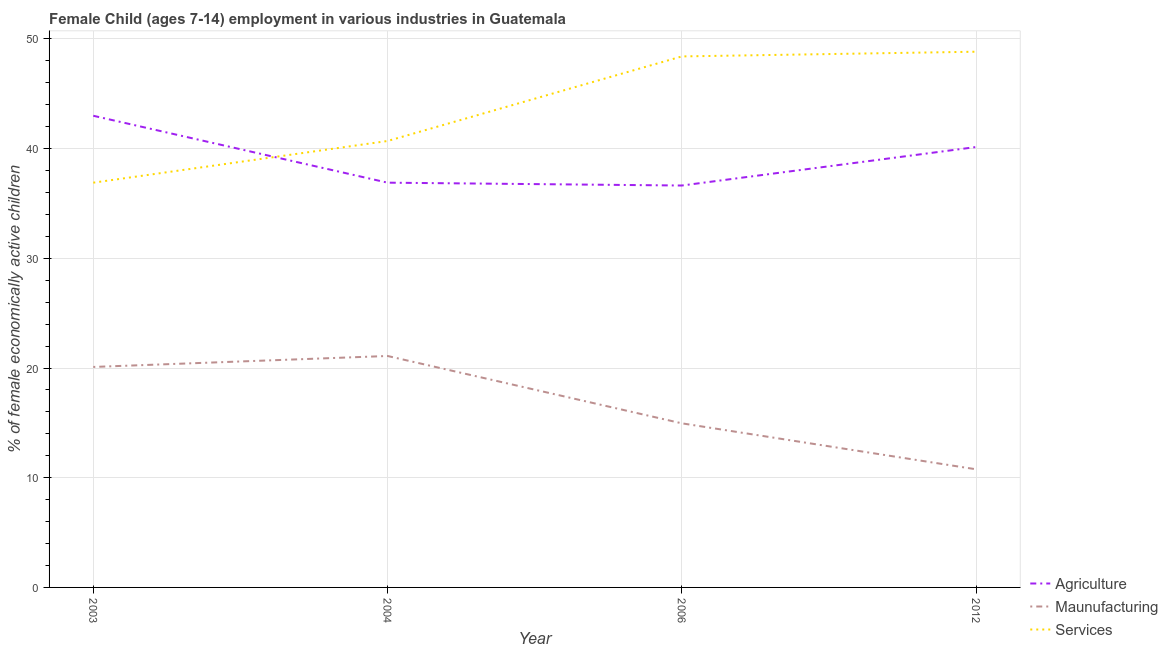Is the number of lines equal to the number of legend labels?
Offer a terse response. Yes. What is the percentage of economically active children in services in 2003?
Your response must be concise. 36.9. Across all years, what is the maximum percentage of economically active children in manufacturing?
Ensure brevity in your answer.  21.1. Across all years, what is the minimum percentage of economically active children in agriculture?
Your answer should be very brief. 36.64. What is the total percentage of economically active children in manufacturing in the graph?
Provide a succinct answer. 66.93. What is the difference between the percentage of economically active children in agriculture in 2003 and that in 2006?
Ensure brevity in your answer.  6.36. What is the difference between the percentage of economically active children in agriculture in 2006 and the percentage of economically active children in services in 2003?
Offer a terse response. -0.26. What is the average percentage of economically active children in manufacturing per year?
Keep it short and to the point. 16.73. In the year 2004, what is the difference between the percentage of economically active children in agriculture and percentage of economically active children in manufacturing?
Provide a succinct answer. 15.8. What is the ratio of the percentage of economically active children in agriculture in 2003 to that in 2004?
Offer a terse response. 1.17. Is the difference between the percentage of economically active children in manufacturing in 2004 and 2012 greater than the difference between the percentage of economically active children in agriculture in 2004 and 2012?
Ensure brevity in your answer.  Yes. What is the difference between the highest and the second highest percentage of economically active children in services?
Make the answer very short. 0.43. What is the difference between the highest and the lowest percentage of economically active children in agriculture?
Keep it short and to the point. 6.36. Is the sum of the percentage of economically active children in services in 2003 and 2012 greater than the maximum percentage of economically active children in manufacturing across all years?
Give a very brief answer. Yes. Is it the case that in every year, the sum of the percentage of economically active children in agriculture and percentage of economically active children in manufacturing is greater than the percentage of economically active children in services?
Offer a terse response. Yes. Does the percentage of economically active children in agriculture monotonically increase over the years?
Your answer should be very brief. No. How many lines are there?
Give a very brief answer. 3. Are the values on the major ticks of Y-axis written in scientific E-notation?
Offer a terse response. No. Does the graph contain grids?
Provide a short and direct response. Yes. Where does the legend appear in the graph?
Your answer should be compact. Bottom right. How many legend labels are there?
Make the answer very short. 3. What is the title of the graph?
Ensure brevity in your answer.  Female Child (ages 7-14) employment in various industries in Guatemala. Does "Profit Tax" appear as one of the legend labels in the graph?
Your response must be concise. No. What is the label or title of the X-axis?
Your answer should be very brief. Year. What is the label or title of the Y-axis?
Provide a short and direct response. % of female economically active children. What is the % of female economically active children in Maunufacturing in 2003?
Provide a succinct answer. 20.1. What is the % of female economically active children in Services in 2003?
Give a very brief answer. 36.9. What is the % of female economically active children of Agriculture in 2004?
Your answer should be very brief. 36.9. What is the % of female economically active children of Maunufacturing in 2004?
Provide a succinct answer. 21.1. What is the % of female economically active children in Services in 2004?
Ensure brevity in your answer.  40.7. What is the % of female economically active children in Agriculture in 2006?
Your response must be concise. 36.64. What is the % of female economically active children in Maunufacturing in 2006?
Make the answer very short. 14.96. What is the % of female economically active children of Services in 2006?
Offer a terse response. 48.41. What is the % of female economically active children of Agriculture in 2012?
Make the answer very short. 40.15. What is the % of female economically active children of Maunufacturing in 2012?
Your answer should be very brief. 10.77. What is the % of female economically active children in Services in 2012?
Ensure brevity in your answer.  48.84. Across all years, what is the maximum % of female economically active children of Maunufacturing?
Make the answer very short. 21.1. Across all years, what is the maximum % of female economically active children of Services?
Offer a very short reply. 48.84. Across all years, what is the minimum % of female economically active children in Agriculture?
Offer a terse response. 36.64. Across all years, what is the minimum % of female economically active children of Maunufacturing?
Your answer should be very brief. 10.77. Across all years, what is the minimum % of female economically active children in Services?
Offer a very short reply. 36.9. What is the total % of female economically active children of Agriculture in the graph?
Offer a terse response. 156.69. What is the total % of female economically active children of Maunufacturing in the graph?
Your response must be concise. 66.93. What is the total % of female economically active children of Services in the graph?
Your answer should be compact. 174.85. What is the difference between the % of female economically active children of Agriculture in 2003 and that in 2004?
Your answer should be compact. 6.1. What is the difference between the % of female economically active children of Agriculture in 2003 and that in 2006?
Ensure brevity in your answer.  6.36. What is the difference between the % of female economically active children of Maunufacturing in 2003 and that in 2006?
Keep it short and to the point. 5.14. What is the difference between the % of female economically active children of Services in 2003 and that in 2006?
Offer a very short reply. -11.51. What is the difference between the % of female economically active children of Agriculture in 2003 and that in 2012?
Your answer should be very brief. 2.85. What is the difference between the % of female economically active children in Maunufacturing in 2003 and that in 2012?
Ensure brevity in your answer.  9.33. What is the difference between the % of female economically active children of Services in 2003 and that in 2012?
Offer a very short reply. -11.94. What is the difference between the % of female economically active children of Agriculture in 2004 and that in 2006?
Keep it short and to the point. 0.26. What is the difference between the % of female economically active children of Maunufacturing in 2004 and that in 2006?
Your answer should be very brief. 6.14. What is the difference between the % of female economically active children of Services in 2004 and that in 2006?
Give a very brief answer. -7.71. What is the difference between the % of female economically active children in Agriculture in 2004 and that in 2012?
Offer a terse response. -3.25. What is the difference between the % of female economically active children of Maunufacturing in 2004 and that in 2012?
Make the answer very short. 10.33. What is the difference between the % of female economically active children in Services in 2004 and that in 2012?
Keep it short and to the point. -8.14. What is the difference between the % of female economically active children of Agriculture in 2006 and that in 2012?
Your answer should be compact. -3.51. What is the difference between the % of female economically active children of Maunufacturing in 2006 and that in 2012?
Offer a terse response. 4.19. What is the difference between the % of female economically active children in Services in 2006 and that in 2012?
Offer a very short reply. -0.43. What is the difference between the % of female economically active children of Agriculture in 2003 and the % of female economically active children of Maunufacturing in 2004?
Offer a terse response. 21.9. What is the difference between the % of female economically active children of Agriculture in 2003 and the % of female economically active children of Services in 2004?
Make the answer very short. 2.3. What is the difference between the % of female economically active children in Maunufacturing in 2003 and the % of female economically active children in Services in 2004?
Your answer should be very brief. -20.6. What is the difference between the % of female economically active children in Agriculture in 2003 and the % of female economically active children in Maunufacturing in 2006?
Make the answer very short. 28.04. What is the difference between the % of female economically active children in Agriculture in 2003 and the % of female economically active children in Services in 2006?
Your response must be concise. -5.41. What is the difference between the % of female economically active children in Maunufacturing in 2003 and the % of female economically active children in Services in 2006?
Keep it short and to the point. -28.31. What is the difference between the % of female economically active children of Agriculture in 2003 and the % of female economically active children of Maunufacturing in 2012?
Make the answer very short. 32.23. What is the difference between the % of female economically active children in Agriculture in 2003 and the % of female economically active children in Services in 2012?
Provide a short and direct response. -5.84. What is the difference between the % of female economically active children in Maunufacturing in 2003 and the % of female economically active children in Services in 2012?
Provide a short and direct response. -28.74. What is the difference between the % of female economically active children of Agriculture in 2004 and the % of female economically active children of Maunufacturing in 2006?
Your response must be concise. 21.94. What is the difference between the % of female economically active children in Agriculture in 2004 and the % of female economically active children in Services in 2006?
Give a very brief answer. -11.51. What is the difference between the % of female economically active children in Maunufacturing in 2004 and the % of female economically active children in Services in 2006?
Offer a very short reply. -27.31. What is the difference between the % of female economically active children of Agriculture in 2004 and the % of female economically active children of Maunufacturing in 2012?
Your response must be concise. 26.13. What is the difference between the % of female economically active children of Agriculture in 2004 and the % of female economically active children of Services in 2012?
Give a very brief answer. -11.94. What is the difference between the % of female economically active children in Maunufacturing in 2004 and the % of female economically active children in Services in 2012?
Your answer should be very brief. -27.74. What is the difference between the % of female economically active children of Agriculture in 2006 and the % of female economically active children of Maunufacturing in 2012?
Ensure brevity in your answer.  25.87. What is the difference between the % of female economically active children of Maunufacturing in 2006 and the % of female economically active children of Services in 2012?
Give a very brief answer. -33.88. What is the average % of female economically active children in Agriculture per year?
Your answer should be very brief. 39.17. What is the average % of female economically active children in Maunufacturing per year?
Make the answer very short. 16.73. What is the average % of female economically active children in Services per year?
Your response must be concise. 43.71. In the year 2003, what is the difference between the % of female economically active children in Agriculture and % of female economically active children in Maunufacturing?
Ensure brevity in your answer.  22.9. In the year 2003, what is the difference between the % of female economically active children in Maunufacturing and % of female economically active children in Services?
Provide a short and direct response. -16.8. In the year 2004, what is the difference between the % of female economically active children of Agriculture and % of female economically active children of Maunufacturing?
Your answer should be very brief. 15.8. In the year 2004, what is the difference between the % of female economically active children of Agriculture and % of female economically active children of Services?
Keep it short and to the point. -3.8. In the year 2004, what is the difference between the % of female economically active children of Maunufacturing and % of female economically active children of Services?
Keep it short and to the point. -19.6. In the year 2006, what is the difference between the % of female economically active children of Agriculture and % of female economically active children of Maunufacturing?
Your answer should be compact. 21.68. In the year 2006, what is the difference between the % of female economically active children in Agriculture and % of female economically active children in Services?
Make the answer very short. -11.77. In the year 2006, what is the difference between the % of female economically active children of Maunufacturing and % of female economically active children of Services?
Ensure brevity in your answer.  -33.45. In the year 2012, what is the difference between the % of female economically active children of Agriculture and % of female economically active children of Maunufacturing?
Provide a succinct answer. 29.38. In the year 2012, what is the difference between the % of female economically active children of Agriculture and % of female economically active children of Services?
Provide a succinct answer. -8.69. In the year 2012, what is the difference between the % of female economically active children of Maunufacturing and % of female economically active children of Services?
Keep it short and to the point. -38.07. What is the ratio of the % of female economically active children of Agriculture in 2003 to that in 2004?
Your response must be concise. 1.17. What is the ratio of the % of female economically active children in Maunufacturing in 2003 to that in 2004?
Provide a succinct answer. 0.95. What is the ratio of the % of female economically active children of Services in 2003 to that in 2004?
Provide a succinct answer. 0.91. What is the ratio of the % of female economically active children of Agriculture in 2003 to that in 2006?
Keep it short and to the point. 1.17. What is the ratio of the % of female economically active children in Maunufacturing in 2003 to that in 2006?
Provide a short and direct response. 1.34. What is the ratio of the % of female economically active children in Services in 2003 to that in 2006?
Keep it short and to the point. 0.76. What is the ratio of the % of female economically active children in Agriculture in 2003 to that in 2012?
Provide a short and direct response. 1.07. What is the ratio of the % of female economically active children of Maunufacturing in 2003 to that in 2012?
Give a very brief answer. 1.87. What is the ratio of the % of female economically active children in Services in 2003 to that in 2012?
Ensure brevity in your answer.  0.76. What is the ratio of the % of female economically active children of Agriculture in 2004 to that in 2006?
Ensure brevity in your answer.  1.01. What is the ratio of the % of female economically active children in Maunufacturing in 2004 to that in 2006?
Make the answer very short. 1.41. What is the ratio of the % of female economically active children in Services in 2004 to that in 2006?
Ensure brevity in your answer.  0.84. What is the ratio of the % of female economically active children of Agriculture in 2004 to that in 2012?
Make the answer very short. 0.92. What is the ratio of the % of female economically active children in Maunufacturing in 2004 to that in 2012?
Give a very brief answer. 1.96. What is the ratio of the % of female economically active children in Agriculture in 2006 to that in 2012?
Your response must be concise. 0.91. What is the ratio of the % of female economically active children in Maunufacturing in 2006 to that in 2012?
Give a very brief answer. 1.39. What is the difference between the highest and the second highest % of female economically active children in Agriculture?
Offer a terse response. 2.85. What is the difference between the highest and the second highest % of female economically active children of Maunufacturing?
Provide a succinct answer. 1. What is the difference between the highest and the second highest % of female economically active children of Services?
Your answer should be compact. 0.43. What is the difference between the highest and the lowest % of female economically active children in Agriculture?
Provide a short and direct response. 6.36. What is the difference between the highest and the lowest % of female economically active children of Maunufacturing?
Offer a very short reply. 10.33. What is the difference between the highest and the lowest % of female economically active children in Services?
Provide a short and direct response. 11.94. 